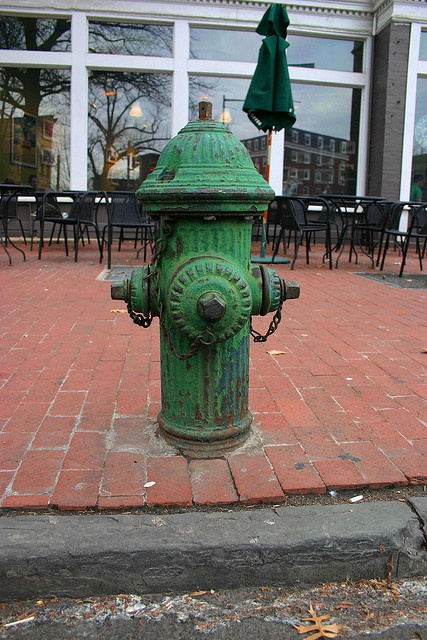Describe the objects in this image and their specific colors. I can see fire hydrant in darkgray, black, darkgreen, gray, and green tones, umbrella in darkgray, black, lavender, teal, and darkgreen tones, chair in darkgray, black, gray, and maroon tones, dining table in darkgray, black, gray, brown, and maroon tones, and chair in darkgray, black, gray, and maroon tones in this image. 